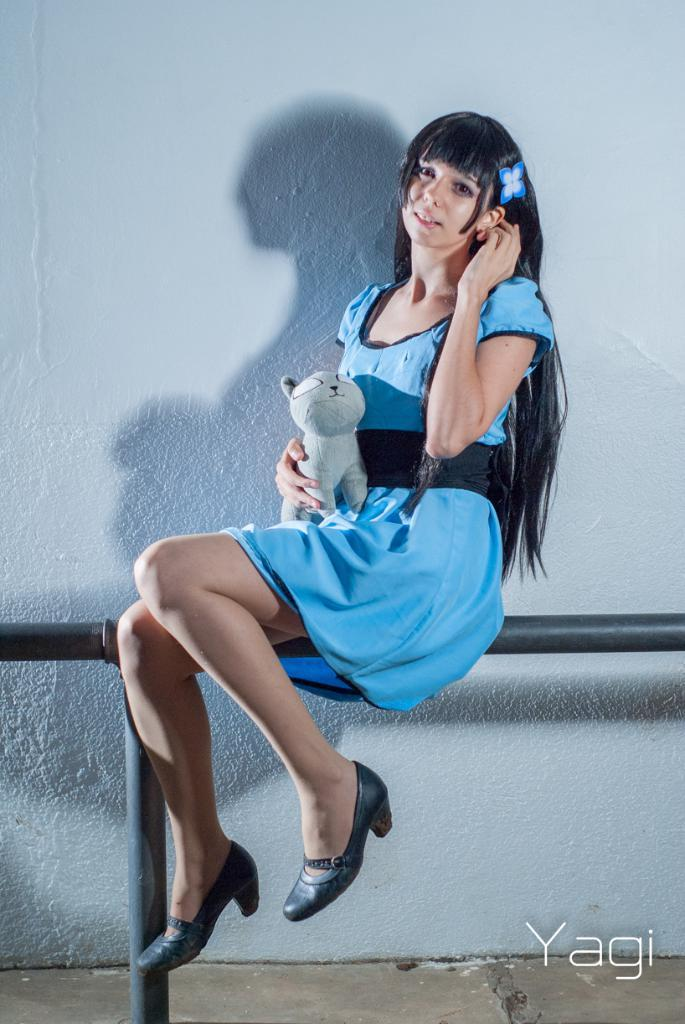What is the woman doing in the image? The woman is sitting on a rod fence in the image. What can be seen in addition to the woman and the fence? There is a text visible in the image. What is visible in the background of the image? There is a wall in the background of the image. When was the image taken? The image was taken during the day. What type of pencil is the woman holding in the image? There is no pencil visible in the image. What does the flag represent in the image? There is no flag present in the image. 